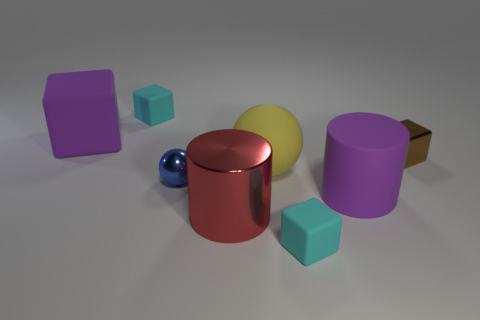Can you describe the other objects in the image apart from the sphere and the cylinder? Certainly! Besides the sphere and cylinder, the image features two cubes with a matte finish—one light blue and another dark blue—and two cylinders, one purple and one yellow. There's also a brown rectangular prism on the far right. 